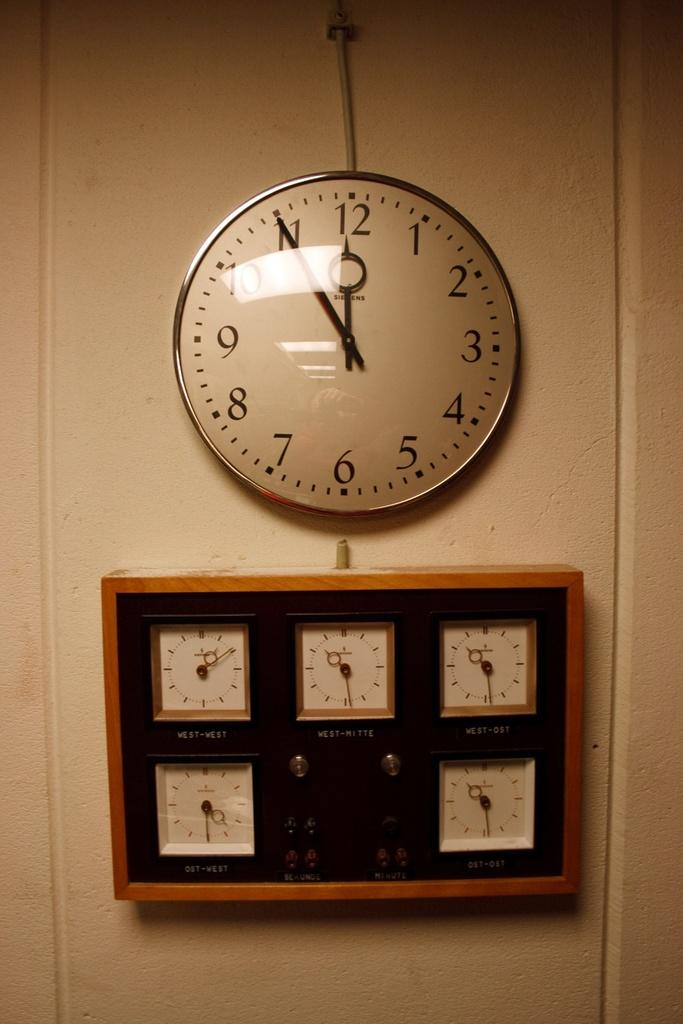<image>
Write a terse but informative summary of the picture. A large white wall clock's time reads 11:55. 